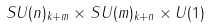Convert formula to latex. <formula><loc_0><loc_0><loc_500><loc_500>S U ( n ) _ { k + m } \times S U ( m ) _ { k + n } \times U ( 1 )</formula> 